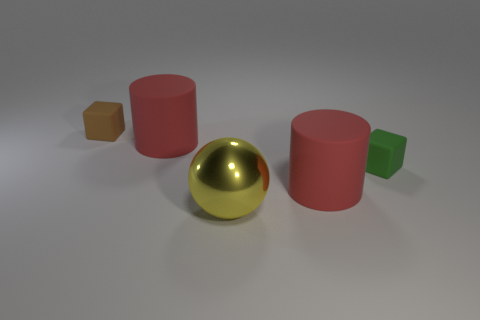Add 4 red metal balls. How many objects exist? 9 Subtract all cubes. How many objects are left? 3 Subtract 0 cyan blocks. How many objects are left? 5 Subtract all big rubber cylinders. Subtract all big rubber cylinders. How many objects are left? 1 Add 2 brown blocks. How many brown blocks are left? 3 Add 5 big red cylinders. How many big red cylinders exist? 7 